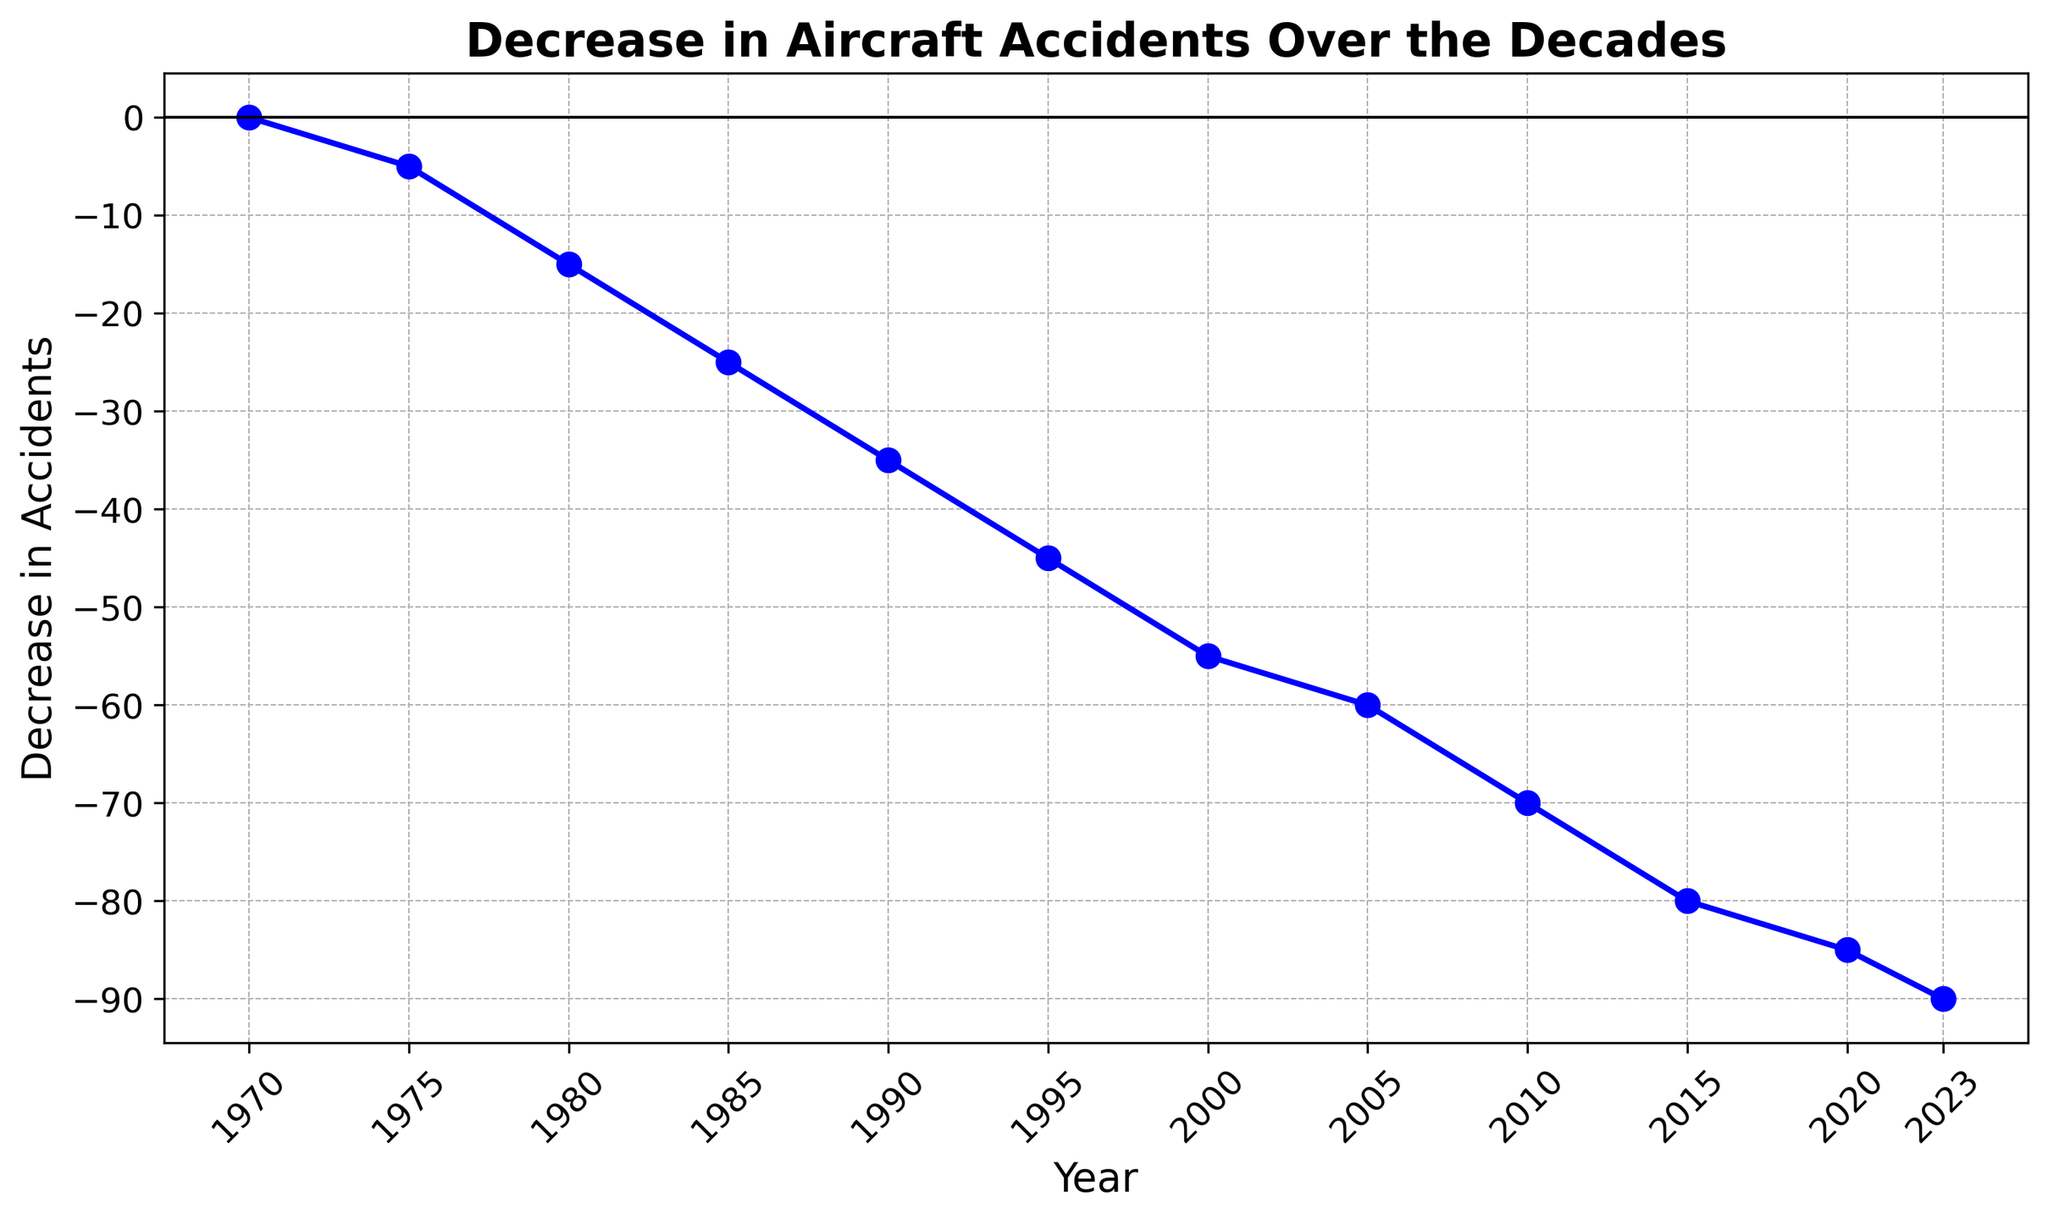What is the overall trend in the decrease of aircraft accidents over the decades? From the line chart, the overall trend shows a continual decrease in the number of aircraft accidents over the decades, starting from 0 in 1970 to -90 in 2023, indicating a significant reduction in accidents.
Answer: Continual decrease By how many accidents did the number of aircraft accidents decrease from 1975 to 2020? In 1975, the decrease in accidents was -5, and in 2020 it was -85. The difference can be calculated as -85 - (-5), which equals -80. Therefore, the number of accidents decreased by 80 from 1975 to 2020.
Answer: 80 Which decade experienced the greatest reduction in the number of aircraft accidents? By examining the line chart, the period from 1970 to 1980 shows the greatest reduction, where the decrease went from 0 to -15. Each decade following has a smaller additional decrease compared to this initial period.
Answer: 1970-1980 How much greater is the decrease in aircraft accidents in 2023 compared to 2005? In 2023, the decrease in accidents is -90, while in 2005 it is -60. The difference between these values is -90 - (-60), which equals -30. Therefore, the decrease in accidents in 2023 is 30 greater compared to 2005.
Answer: 30 At which point did the number of aircraft accidents decrease by 10 more compared to the year 1980? In 1980, the decrease was -15. For a decrease of 10 more than this, we need to find a value of -25. This value is reached in 1985.
Answer: 1985 How much did the decrease in aircraft accidents change between 1995 and 2005? In 1995, the decrease in accidents was -45, and in 2005 it was -60. The change can be calculated as -60 - (-45), which equals -15. Thus, the decrease changed by 15 between 1995 and 2005.
Answer: 15 What is the average decrease in the number of aircraft accidents per decade from 1970 to 2023? To find the average, we first identify the total decrease from 1970 (0) to 2023 (-90), which is 90. This change occurs over approximately 5 decades (1970-1980, 1980-1990, 1990-2000, 2000-2010, 2010-2020). The average decrease per decade is 90 / 5, which equals 18.
Answer: 18 Based on the visual, does the decrease in accidents become more rapid or gradual over time? Observing the line chart, the decrease seems to be more rapid initially (1970-1980), then becomes more gradual, though consistently decreasing, stabilizing into a smoother decline towards the later decades.
Answer: More gradual Are there any gaps in the data, or is the decrease in accidents represented continuously over the decades? The line in the chart is continuous from 1970 to 2023 without any gaps. This indicates that the data presents a continuous decrease in accidents over these years.
Answer: Continuous 